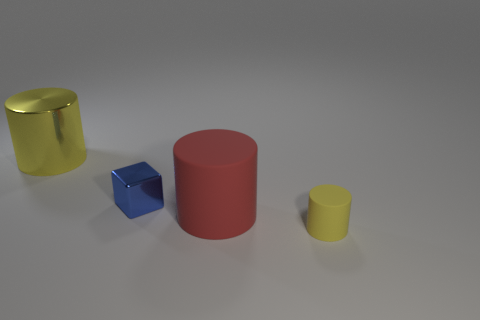Subtract all large red cylinders. How many cylinders are left? 2 Subtract all yellow cylinders. How many cylinders are left? 1 Add 3 tiny blue metallic cubes. How many objects exist? 7 Subtract all cylinders. How many objects are left? 1 Subtract all brown blocks. How many yellow cylinders are left? 2 Subtract all brown cubes. Subtract all brown cylinders. How many cubes are left? 1 Subtract all small yellow matte things. Subtract all tiny brown metallic objects. How many objects are left? 3 Add 2 metal cylinders. How many metal cylinders are left? 3 Add 4 metal objects. How many metal objects exist? 6 Subtract 0 green balls. How many objects are left? 4 